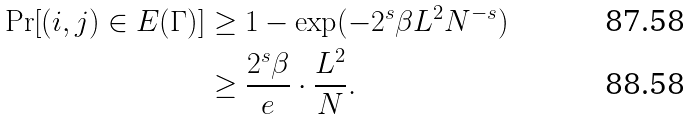<formula> <loc_0><loc_0><loc_500><loc_500>\Pr [ ( i , j ) \in E ( \Gamma ) ] & \geq 1 - \exp ( - 2 ^ { s } \beta L ^ { 2 } N ^ { - s } ) \\ & \geq \frac { 2 ^ { s } \beta } { e } \cdot \frac { L ^ { 2 } } { N } .</formula> 